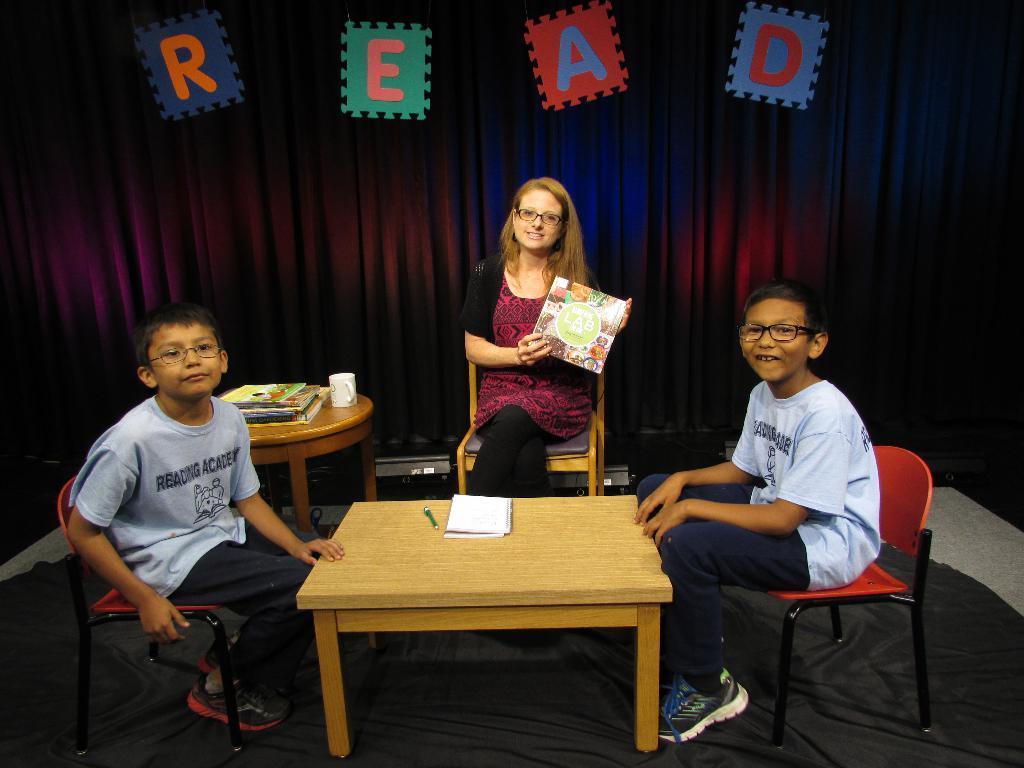Please provide a concise description of this image. A woman sat in a chair holding a card in her hand. There are two boys on either side of table with a book and pen on it. There are few books on stool beside the woman. There is curtain labelled "read" on it. 